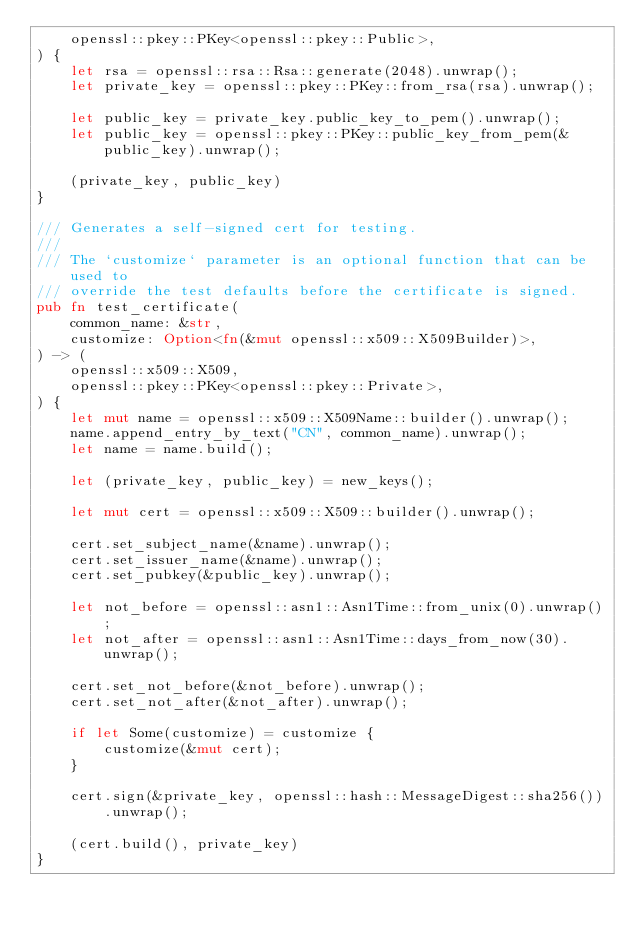<code> <loc_0><loc_0><loc_500><loc_500><_Rust_>    openssl::pkey::PKey<openssl::pkey::Public>,
) {
    let rsa = openssl::rsa::Rsa::generate(2048).unwrap();
    let private_key = openssl::pkey::PKey::from_rsa(rsa).unwrap();

    let public_key = private_key.public_key_to_pem().unwrap();
    let public_key = openssl::pkey::PKey::public_key_from_pem(&public_key).unwrap();

    (private_key, public_key)
}

/// Generates a self-signed cert for testing.
///
/// The `customize` parameter is an optional function that can be used to
/// override the test defaults before the certificate is signed.
pub fn test_certificate(
    common_name: &str,
    customize: Option<fn(&mut openssl::x509::X509Builder)>,
) -> (
    openssl::x509::X509,
    openssl::pkey::PKey<openssl::pkey::Private>,
) {
    let mut name = openssl::x509::X509Name::builder().unwrap();
    name.append_entry_by_text("CN", common_name).unwrap();
    let name = name.build();

    let (private_key, public_key) = new_keys();

    let mut cert = openssl::x509::X509::builder().unwrap();

    cert.set_subject_name(&name).unwrap();
    cert.set_issuer_name(&name).unwrap();
    cert.set_pubkey(&public_key).unwrap();

    let not_before = openssl::asn1::Asn1Time::from_unix(0).unwrap();
    let not_after = openssl::asn1::Asn1Time::days_from_now(30).unwrap();

    cert.set_not_before(&not_before).unwrap();
    cert.set_not_after(&not_after).unwrap();

    if let Some(customize) = customize {
        customize(&mut cert);
    }

    cert.sign(&private_key, openssl::hash::MessageDigest::sha256())
        .unwrap();

    (cert.build(), private_key)
}
</code> 